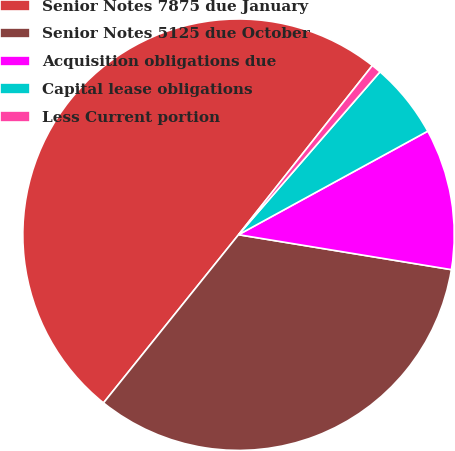Convert chart. <chart><loc_0><loc_0><loc_500><loc_500><pie_chart><fcel>Senior Notes 7875 due January<fcel>Senior Notes 5125 due October<fcel>Acquisition obligations due<fcel>Capital lease obligations<fcel>Less Current portion<nl><fcel>49.89%<fcel>33.18%<fcel>10.56%<fcel>5.65%<fcel>0.73%<nl></chart> 